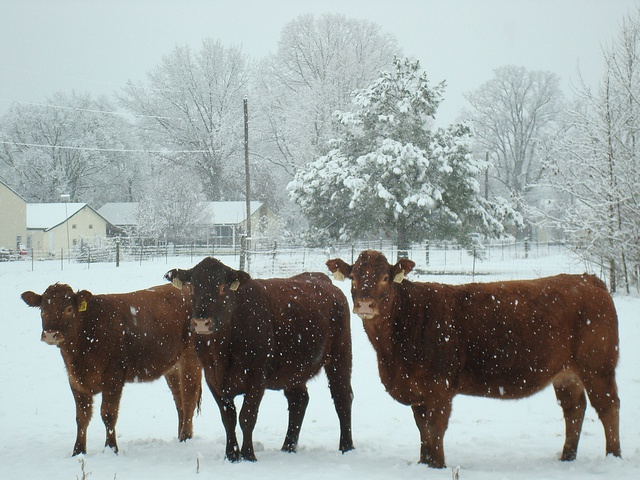Describe the objects in this image and their specific colors. I can see cow in lightgray, black, maroon, and gray tones, cow in lightgray, black, and gray tones, and cow in lightgray, black, maroon, and gray tones in this image. 